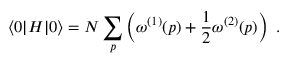Convert formula to latex. <formula><loc_0><loc_0><loc_500><loc_500>\langle 0 | H | 0 \rangle = N \sum _ { p } \left ( \omega ^ { ( 1 ) } ( p ) + \frac { 1 } { 2 } \omega ^ { ( 2 ) } ( p ) \right ) \ .</formula> 